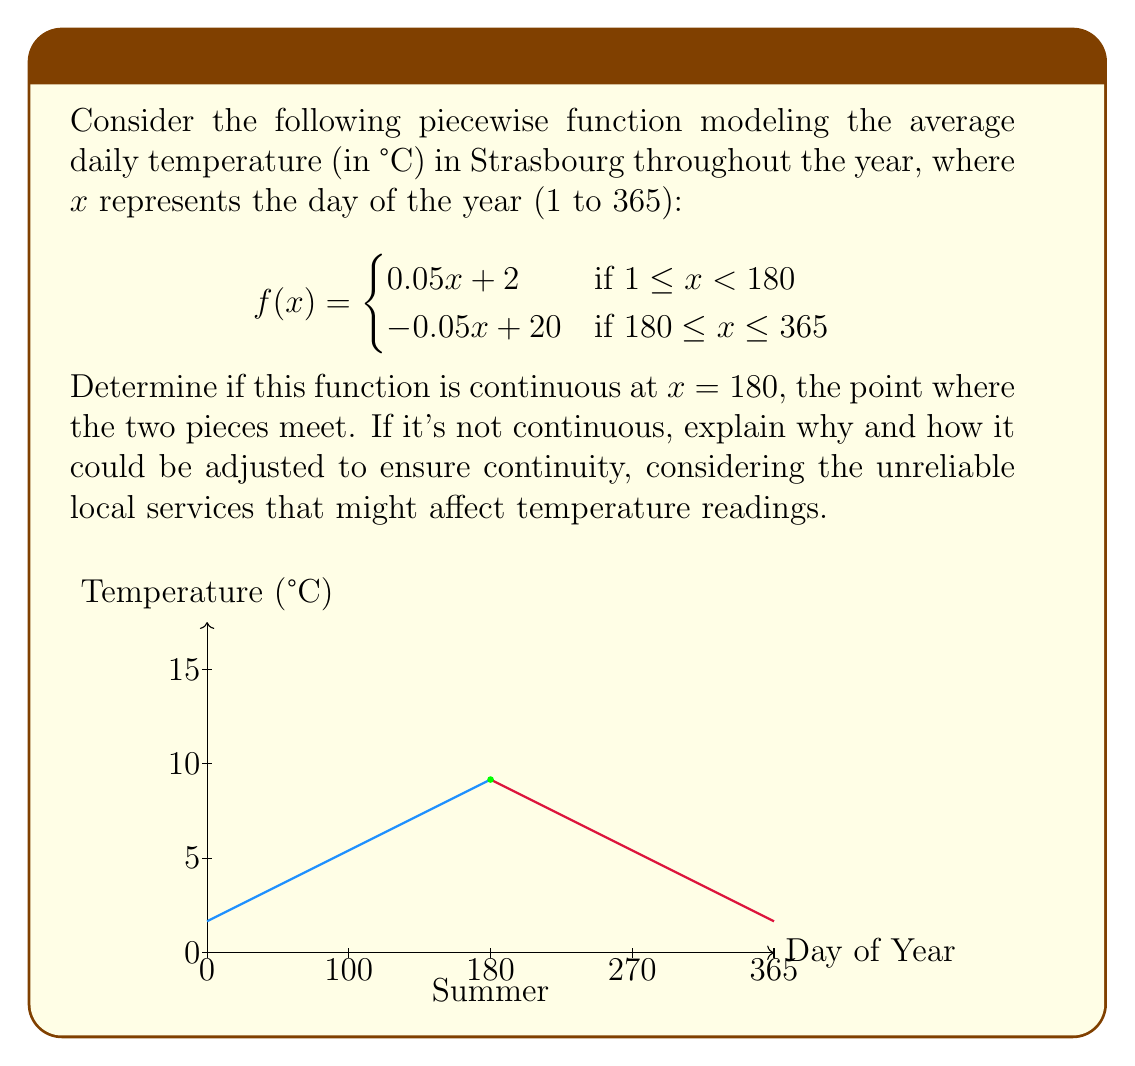Could you help me with this problem? To determine if the function is continuous at $x = 180$, we need to check three conditions:

1. $f(180)$ exists
2. $\lim_{x \to 180^-} f(x)$ exists
3. $\lim_{x \to 180^+} f(x)$ exists
4. All three values are equal

Let's evaluate each condition:

1. $f(180)$ exists for both pieces:
   Left piece: $f(180) = 0.05(180) + 2 = 11$
   Right piece: $f(180) = -0.05(180) + 20 = 11$

2. $\lim_{x \to 180^-} f(x) = \lim_{x \to 180^-} (0.05x + 2) = 0.05(180) + 2 = 11$

3. $\lim_{x \to 180^+} f(x) = \lim_{x \to 180^+} (-0.05x + 20) = -0.05(180) + 20 = 11$

4. All three values are equal to 11.

Since all conditions are satisfied, the function is continuous at $x = 180$.

However, considering the unreliable local services that might affect temperature readings, we should note that this perfect continuity might not reflect real-world conditions. In practice, there could be small discrepancies due to measurement errors or sudden weather changes. To account for this, we could introduce a small tolerance ε in our continuity check:

$$|f(180^-) - f(180^+)| < \varepsilon$$

Where ε represents the maximum acceptable difference in temperature readings due to measurement inaccuracies or local service inconsistencies.
Answer: The function is continuous at $x = 180$. 